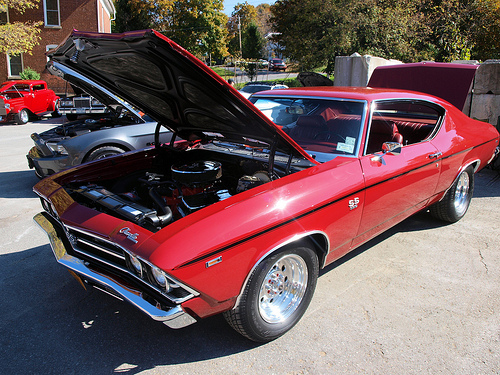<image>
Can you confirm if the wall is behind the car? Yes. From this viewpoint, the wall is positioned behind the car, with the car partially or fully occluding the wall. 